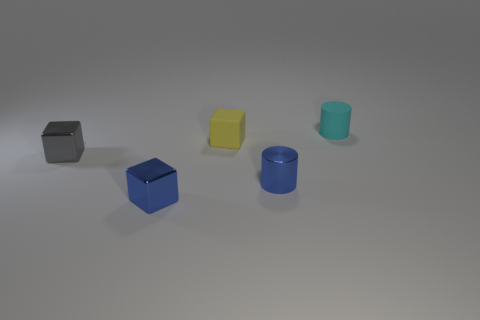What color is the matte thing in front of the small cyan matte object?
Ensure brevity in your answer.  Yellow. What is the material of the tiny cylinder that is right of the tiny cylinder that is to the left of the cylinder that is behind the gray block?
Give a very brief answer. Rubber. What is the color of the metallic object that is the same shape as the tiny cyan rubber thing?
Your answer should be very brief. Blue. What number of other tiny matte cylinders are the same color as the matte cylinder?
Your answer should be compact. 0. Is the size of the blue metallic cube the same as the matte cylinder?
Offer a very short reply. Yes. What is the tiny blue cylinder made of?
Offer a very short reply. Metal. What is the color of the cube that is the same material as the small cyan object?
Ensure brevity in your answer.  Yellow. Do the small blue cylinder and the block that is behind the tiny gray shiny thing have the same material?
Keep it short and to the point. No. How many other yellow objects are made of the same material as the yellow object?
Your answer should be very brief. 0. What is the shape of the cyan thing to the right of the small blue metal cube?
Make the answer very short. Cylinder. 